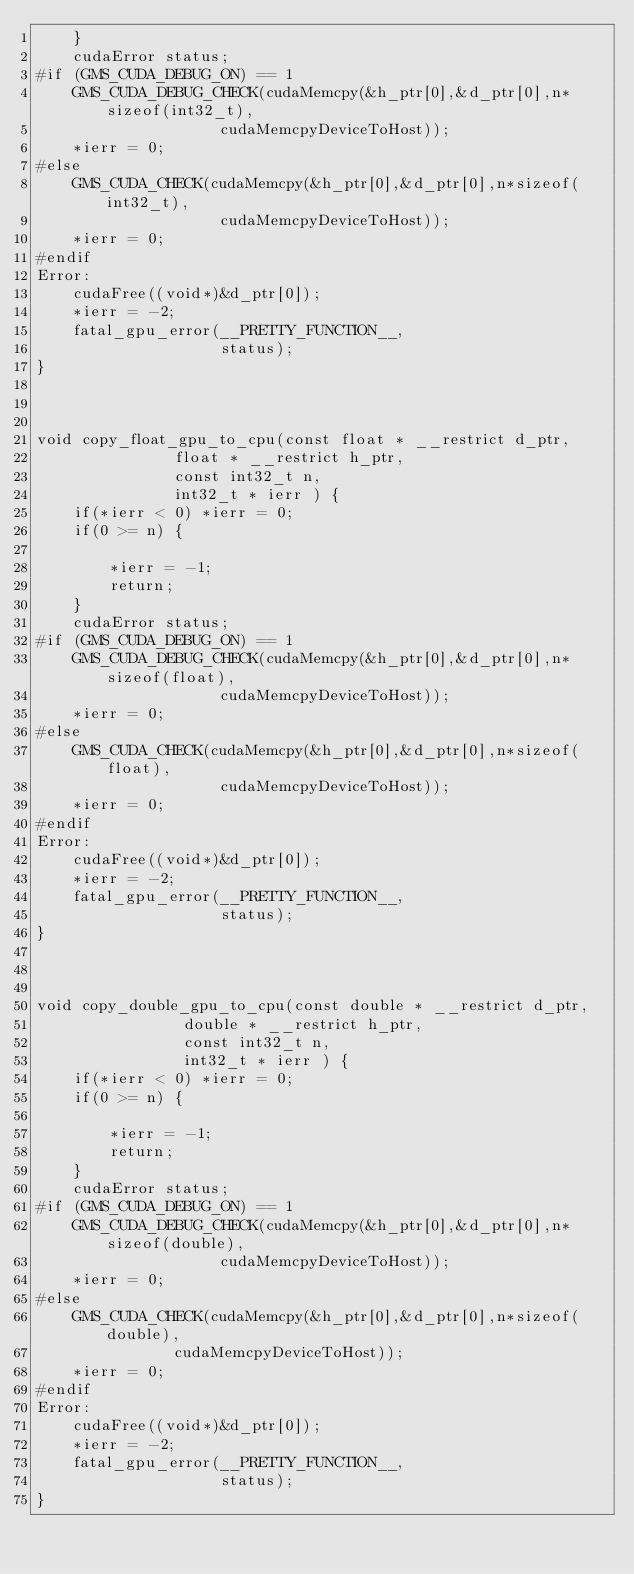<code> <loc_0><loc_0><loc_500><loc_500><_Cuda_>	}
	cudaError status;
#if (GMS_CUDA_DEBUG_ON) == 1
	GMS_CUDA_DEBUG_CHECK(cudaMemcpy(&h_ptr[0],&d_ptr[0],n*sizeof(int32_t),
					cudaMemcpyDeviceToHost));
	*ierr = 0;
#else
	GMS_CUDA_CHECK(cudaMemcpy(&h_ptr[0],&d_ptr[0],n*sizeof(int32_t),
					cudaMemcpyDeviceToHost));
	*ierr = 0;
#endif
Error:
	cudaFree((void*)&d_ptr[0]);
	*ierr = -2;
	fatal_gpu_error(__PRETTY_FUNCTION__,
		            status);
}



void copy_float_gpu_to_cpu(const float * __restrict d_ptr,
			   float * __restrict h_ptr,
			   const int32_t n,
			   int32_t * ierr ) {
	if(*ierr < 0) *ierr = 0;
	if(0 >= n) {

		*ierr = -1;
		return;
	}
	cudaError status;
#if (GMS_CUDA_DEBUG_ON) == 1
	GMS_CUDA_DEBUG_CHECK(cudaMemcpy(&h_ptr[0],&d_ptr[0],n*sizeof(float),
					cudaMemcpyDeviceToHost));
	*ierr = 0;
#else
	GMS_CUDA_CHECK(cudaMemcpy(&h_ptr[0],&d_ptr[0],n*sizeof(float),
					cudaMemcpyDeviceToHost));
	*ierr = 0;
#endif
Error:
	cudaFree((void*)&d_ptr[0]);
	*ierr = -2;
	fatal_gpu_error(__PRETTY_FUNCTION__,
		            status);
}



void copy_double_gpu_to_cpu(const double * __restrict d_ptr,
			    double * __restrict h_ptr,
			    const int32_t n,
			    int32_t * ierr ) {
	if(*ierr < 0) *ierr = 0;
	if(0 >= n) {

		*ierr = -1;
		return;
	}
	cudaError status;
#if (GMS_CUDA_DEBUG_ON) == 1
	GMS_CUDA_DEBUG_CHECK(cudaMemcpy(&h_ptr[0],&d_ptr[0],n*sizeof(double),
					cudaMemcpyDeviceToHost));
	*ierr = 0;
#else
	GMS_CUDA_CHECK(cudaMemcpy(&h_ptr[0],&d_ptr[0],n*sizeof(double),
			   cudaMemcpyDeviceToHost));
	*ierr = 0;
#endif
Error:
	cudaFree((void*)&d_ptr[0]);
	*ierr = -2;
	fatal_gpu_error(__PRETTY_FUNCTION__,
		            status);
}

























</code> 